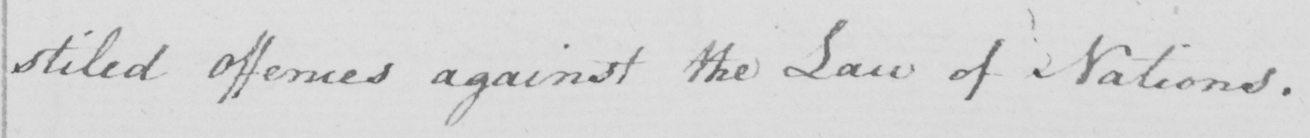Transcribe the text shown in this historical manuscript line. stiled Offences against the Law of Nations . 